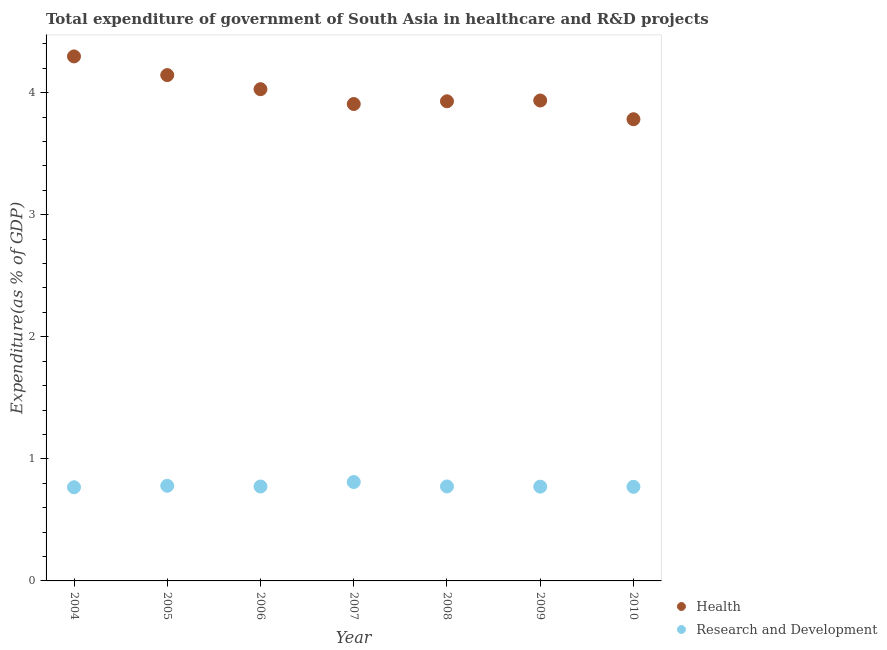Is the number of dotlines equal to the number of legend labels?
Provide a short and direct response. Yes. What is the expenditure in healthcare in 2006?
Ensure brevity in your answer.  4.03. Across all years, what is the maximum expenditure in healthcare?
Offer a terse response. 4.3. Across all years, what is the minimum expenditure in r&d?
Ensure brevity in your answer.  0.77. What is the total expenditure in healthcare in the graph?
Your answer should be very brief. 28.02. What is the difference between the expenditure in r&d in 2008 and that in 2009?
Your answer should be compact. 0. What is the difference between the expenditure in r&d in 2010 and the expenditure in healthcare in 2008?
Your answer should be very brief. -3.16. What is the average expenditure in healthcare per year?
Offer a very short reply. 4. In the year 2006, what is the difference between the expenditure in healthcare and expenditure in r&d?
Your answer should be very brief. 3.25. What is the ratio of the expenditure in healthcare in 2007 to that in 2009?
Give a very brief answer. 0.99. Is the expenditure in r&d in 2008 less than that in 2010?
Make the answer very short. No. Is the difference between the expenditure in r&d in 2006 and 2010 greater than the difference between the expenditure in healthcare in 2006 and 2010?
Make the answer very short. No. What is the difference between the highest and the second highest expenditure in healthcare?
Give a very brief answer. 0.15. What is the difference between the highest and the lowest expenditure in healthcare?
Offer a very short reply. 0.51. In how many years, is the expenditure in r&d greater than the average expenditure in r&d taken over all years?
Your answer should be compact. 2. Does the expenditure in healthcare monotonically increase over the years?
Give a very brief answer. No. Is the expenditure in r&d strictly greater than the expenditure in healthcare over the years?
Your answer should be compact. No. Is the expenditure in healthcare strictly less than the expenditure in r&d over the years?
Make the answer very short. No. How many dotlines are there?
Provide a short and direct response. 2. How many years are there in the graph?
Your answer should be very brief. 7. Does the graph contain any zero values?
Your response must be concise. No. How are the legend labels stacked?
Your answer should be compact. Vertical. What is the title of the graph?
Ensure brevity in your answer.  Total expenditure of government of South Asia in healthcare and R&D projects. Does "Savings" appear as one of the legend labels in the graph?
Give a very brief answer. No. What is the label or title of the Y-axis?
Offer a very short reply. Expenditure(as % of GDP). What is the Expenditure(as % of GDP) of Health in 2004?
Offer a very short reply. 4.3. What is the Expenditure(as % of GDP) of Research and Development in 2004?
Your answer should be compact. 0.77. What is the Expenditure(as % of GDP) of Health in 2005?
Offer a terse response. 4.14. What is the Expenditure(as % of GDP) of Research and Development in 2005?
Provide a succinct answer. 0.78. What is the Expenditure(as % of GDP) of Health in 2006?
Make the answer very short. 4.03. What is the Expenditure(as % of GDP) of Research and Development in 2006?
Your answer should be compact. 0.77. What is the Expenditure(as % of GDP) of Health in 2007?
Give a very brief answer. 3.91. What is the Expenditure(as % of GDP) in Research and Development in 2007?
Your answer should be very brief. 0.81. What is the Expenditure(as % of GDP) in Health in 2008?
Provide a succinct answer. 3.93. What is the Expenditure(as % of GDP) of Research and Development in 2008?
Your response must be concise. 0.77. What is the Expenditure(as % of GDP) in Health in 2009?
Offer a very short reply. 3.94. What is the Expenditure(as % of GDP) of Research and Development in 2009?
Offer a very short reply. 0.77. What is the Expenditure(as % of GDP) in Health in 2010?
Your answer should be very brief. 3.78. What is the Expenditure(as % of GDP) in Research and Development in 2010?
Your answer should be compact. 0.77. Across all years, what is the maximum Expenditure(as % of GDP) of Health?
Your answer should be very brief. 4.3. Across all years, what is the maximum Expenditure(as % of GDP) in Research and Development?
Provide a succinct answer. 0.81. Across all years, what is the minimum Expenditure(as % of GDP) in Health?
Provide a short and direct response. 3.78. Across all years, what is the minimum Expenditure(as % of GDP) in Research and Development?
Keep it short and to the point. 0.77. What is the total Expenditure(as % of GDP) of Health in the graph?
Offer a very short reply. 28.02. What is the total Expenditure(as % of GDP) in Research and Development in the graph?
Provide a succinct answer. 5.45. What is the difference between the Expenditure(as % of GDP) of Health in 2004 and that in 2005?
Provide a short and direct response. 0.15. What is the difference between the Expenditure(as % of GDP) of Research and Development in 2004 and that in 2005?
Your answer should be very brief. -0.01. What is the difference between the Expenditure(as % of GDP) in Health in 2004 and that in 2006?
Provide a short and direct response. 0.27. What is the difference between the Expenditure(as % of GDP) of Research and Development in 2004 and that in 2006?
Provide a short and direct response. -0.01. What is the difference between the Expenditure(as % of GDP) of Health in 2004 and that in 2007?
Offer a terse response. 0.39. What is the difference between the Expenditure(as % of GDP) of Research and Development in 2004 and that in 2007?
Your answer should be compact. -0.04. What is the difference between the Expenditure(as % of GDP) of Health in 2004 and that in 2008?
Offer a terse response. 0.37. What is the difference between the Expenditure(as % of GDP) in Research and Development in 2004 and that in 2008?
Give a very brief answer. -0.01. What is the difference between the Expenditure(as % of GDP) in Health in 2004 and that in 2009?
Offer a very short reply. 0.36. What is the difference between the Expenditure(as % of GDP) of Research and Development in 2004 and that in 2009?
Ensure brevity in your answer.  -0.01. What is the difference between the Expenditure(as % of GDP) of Health in 2004 and that in 2010?
Ensure brevity in your answer.  0.51. What is the difference between the Expenditure(as % of GDP) of Research and Development in 2004 and that in 2010?
Ensure brevity in your answer.  -0. What is the difference between the Expenditure(as % of GDP) in Health in 2005 and that in 2006?
Keep it short and to the point. 0.12. What is the difference between the Expenditure(as % of GDP) in Research and Development in 2005 and that in 2006?
Provide a succinct answer. 0.01. What is the difference between the Expenditure(as % of GDP) in Health in 2005 and that in 2007?
Make the answer very short. 0.24. What is the difference between the Expenditure(as % of GDP) in Research and Development in 2005 and that in 2007?
Keep it short and to the point. -0.03. What is the difference between the Expenditure(as % of GDP) of Health in 2005 and that in 2008?
Provide a short and direct response. 0.21. What is the difference between the Expenditure(as % of GDP) of Research and Development in 2005 and that in 2008?
Provide a short and direct response. 0.01. What is the difference between the Expenditure(as % of GDP) of Health in 2005 and that in 2009?
Give a very brief answer. 0.21. What is the difference between the Expenditure(as % of GDP) in Research and Development in 2005 and that in 2009?
Give a very brief answer. 0.01. What is the difference between the Expenditure(as % of GDP) of Health in 2005 and that in 2010?
Offer a terse response. 0.36. What is the difference between the Expenditure(as % of GDP) of Research and Development in 2005 and that in 2010?
Provide a succinct answer. 0.01. What is the difference between the Expenditure(as % of GDP) in Health in 2006 and that in 2007?
Provide a short and direct response. 0.12. What is the difference between the Expenditure(as % of GDP) in Research and Development in 2006 and that in 2007?
Offer a terse response. -0.04. What is the difference between the Expenditure(as % of GDP) of Health in 2006 and that in 2008?
Your answer should be very brief. 0.1. What is the difference between the Expenditure(as % of GDP) in Research and Development in 2006 and that in 2008?
Your answer should be compact. -0. What is the difference between the Expenditure(as % of GDP) of Health in 2006 and that in 2009?
Offer a terse response. 0.09. What is the difference between the Expenditure(as % of GDP) in Research and Development in 2006 and that in 2009?
Provide a succinct answer. 0. What is the difference between the Expenditure(as % of GDP) of Health in 2006 and that in 2010?
Keep it short and to the point. 0.25. What is the difference between the Expenditure(as % of GDP) in Research and Development in 2006 and that in 2010?
Make the answer very short. 0. What is the difference between the Expenditure(as % of GDP) of Health in 2007 and that in 2008?
Your answer should be very brief. -0.02. What is the difference between the Expenditure(as % of GDP) in Research and Development in 2007 and that in 2008?
Your response must be concise. 0.04. What is the difference between the Expenditure(as % of GDP) in Health in 2007 and that in 2009?
Your answer should be very brief. -0.03. What is the difference between the Expenditure(as % of GDP) of Research and Development in 2007 and that in 2009?
Ensure brevity in your answer.  0.04. What is the difference between the Expenditure(as % of GDP) of Health in 2007 and that in 2010?
Provide a short and direct response. 0.12. What is the difference between the Expenditure(as % of GDP) of Research and Development in 2007 and that in 2010?
Make the answer very short. 0.04. What is the difference between the Expenditure(as % of GDP) in Health in 2008 and that in 2009?
Offer a terse response. -0.01. What is the difference between the Expenditure(as % of GDP) in Research and Development in 2008 and that in 2009?
Make the answer very short. 0. What is the difference between the Expenditure(as % of GDP) of Health in 2008 and that in 2010?
Your response must be concise. 0.15. What is the difference between the Expenditure(as % of GDP) of Research and Development in 2008 and that in 2010?
Offer a terse response. 0. What is the difference between the Expenditure(as % of GDP) of Health in 2009 and that in 2010?
Your answer should be very brief. 0.15. What is the difference between the Expenditure(as % of GDP) in Research and Development in 2009 and that in 2010?
Give a very brief answer. 0. What is the difference between the Expenditure(as % of GDP) in Health in 2004 and the Expenditure(as % of GDP) in Research and Development in 2005?
Ensure brevity in your answer.  3.52. What is the difference between the Expenditure(as % of GDP) in Health in 2004 and the Expenditure(as % of GDP) in Research and Development in 2006?
Make the answer very short. 3.52. What is the difference between the Expenditure(as % of GDP) of Health in 2004 and the Expenditure(as % of GDP) of Research and Development in 2007?
Provide a short and direct response. 3.49. What is the difference between the Expenditure(as % of GDP) of Health in 2004 and the Expenditure(as % of GDP) of Research and Development in 2008?
Your answer should be very brief. 3.52. What is the difference between the Expenditure(as % of GDP) of Health in 2004 and the Expenditure(as % of GDP) of Research and Development in 2009?
Keep it short and to the point. 3.52. What is the difference between the Expenditure(as % of GDP) in Health in 2004 and the Expenditure(as % of GDP) in Research and Development in 2010?
Keep it short and to the point. 3.53. What is the difference between the Expenditure(as % of GDP) of Health in 2005 and the Expenditure(as % of GDP) of Research and Development in 2006?
Provide a succinct answer. 3.37. What is the difference between the Expenditure(as % of GDP) of Health in 2005 and the Expenditure(as % of GDP) of Research and Development in 2007?
Your answer should be very brief. 3.33. What is the difference between the Expenditure(as % of GDP) in Health in 2005 and the Expenditure(as % of GDP) in Research and Development in 2008?
Provide a succinct answer. 3.37. What is the difference between the Expenditure(as % of GDP) in Health in 2005 and the Expenditure(as % of GDP) in Research and Development in 2009?
Keep it short and to the point. 3.37. What is the difference between the Expenditure(as % of GDP) in Health in 2005 and the Expenditure(as % of GDP) in Research and Development in 2010?
Your answer should be very brief. 3.37. What is the difference between the Expenditure(as % of GDP) in Health in 2006 and the Expenditure(as % of GDP) in Research and Development in 2007?
Your response must be concise. 3.22. What is the difference between the Expenditure(as % of GDP) of Health in 2006 and the Expenditure(as % of GDP) of Research and Development in 2008?
Give a very brief answer. 3.25. What is the difference between the Expenditure(as % of GDP) in Health in 2006 and the Expenditure(as % of GDP) in Research and Development in 2009?
Keep it short and to the point. 3.26. What is the difference between the Expenditure(as % of GDP) in Health in 2006 and the Expenditure(as % of GDP) in Research and Development in 2010?
Keep it short and to the point. 3.26. What is the difference between the Expenditure(as % of GDP) of Health in 2007 and the Expenditure(as % of GDP) of Research and Development in 2008?
Give a very brief answer. 3.13. What is the difference between the Expenditure(as % of GDP) in Health in 2007 and the Expenditure(as % of GDP) in Research and Development in 2009?
Make the answer very short. 3.13. What is the difference between the Expenditure(as % of GDP) in Health in 2007 and the Expenditure(as % of GDP) in Research and Development in 2010?
Make the answer very short. 3.14. What is the difference between the Expenditure(as % of GDP) of Health in 2008 and the Expenditure(as % of GDP) of Research and Development in 2009?
Your answer should be compact. 3.16. What is the difference between the Expenditure(as % of GDP) of Health in 2008 and the Expenditure(as % of GDP) of Research and Development in 2010?
Keep it short and to the point. 3.16. What is the difference between the Expenditure(as % of GDP) of Health in 2009 and the Expenditure(as % of GDP) of Research and Development in 2010?
Your answer should be compact. 3.16. What is the average Expenditure(as % of GDP) of Health per year?
Provide a succinct answer. 4. What is the average Expenditure(as % of GDP) of Research and Development per year?
Provide a succinct answer. 0.78. In the year 2004, what is the difference between the Expenditure(as % of GDP) in Health and Expenditure(as % of GDP) in Research and Development?
Your response must be concise. 3.53. In the year 2005, what is the difference between the Expenditure(as % of GDP) in Health and Expenditure(as % of GDP) in Research and Development?
Keep it short and to the point. 3.36. In the year 2006, what is the difference between the Expenditure(as % of GDP) of Health and Expenditure(as % of GDP) of Research and Development?
Provide a short and direct response. 3.25. In the year 2007, what is the difference between the Expenditure(as % of GDP) in Health and Expenditure(as % of GDP) in Research and Development?
Ensure brevity in your answer.  3.1. In the year 2008, what is the difference between the Expenditure(as % of GDP) in Health and Expenditure(as % of GDP) in Research and Development?
Provide a succinct answer. 3.16. In the year 2009, what is the difference between the Expenditure(as % of GDP) in Health and Expenditure(as % of GDP) in Research and Development?
Provide a short and direct response. 3.16. In the year 2010, what is the difference between the Expenditure(as % of GDP) in Health and Expenditure(as % of GDP) in Research and Development?
Your answer should be compact. 3.01. What is the ratio of the Expenditure(as % of GDP) in Health in 2004 to that in 2005?
Make the answer very short. 1.04. What is the ratio of the Expenditure(as % of GDP) of Research and Development in 2004 to that in 2005?
Offer a very short reply. 0.98. What is the ratio of the Expenditure(as % of GDP) of Health in 2004 to that in 2006?
Your answer should be compact. 1.07. What is the ratio of the Expenditure(as % of GDP) of Research and Development in 2004 to that in 2006?
Provide a short and direct response. 0.99. What is the ratio of the Expenditure(as % of GDP) of Health in 2004 to that in 2007?
Your answer should be compact. 1.1. What is the ratio of the Expenditure(as % of GDP) of Research and Development in 2004 to that in 2007?
Your answer should be very brief. 0.95. What is the ratio of the Expenditure(as % of GDP) of Health in 2004 to that in 2008?
Your answer should be compact. 1.09. What is the ratio of the Expenditure(as % of GDP) of Research and Development in 2004 to that in 2008?
Make the answer very short. 0.99. What is the ratio of the Expenditure(as % of GDP) of Health in 2004 to that in 2009?
Offer a terse response. 1.09. What is the ratio of the Expenditure(as % of GDP) in Health in 2004 to that in 2010?
Offer a terse response. 1.14. What is the ratio of the Expenditure(as % of GDP) in Research and Development in 2004 to that in 2010?
Provide a succinct answer. 1. What is the ratio of the Expenditure(as % of GDP) in Health in 2005 to that in 2006?
Make the answer very short. 1.03. What is the ratio of the Expenditure(as % of GDP) in Research and Development in 2005 to that in 2006?
Your response must be concise. 1.01. What is the ratio of the Expenditure(as % of GDP) in Health in 2005 to that in 2007?
Offer a very short reply. 1.06. What is the ratio of the Expenditure(as % of GDP) in Research and Development in 2005 to that in 2007?
Keep it short and to the point. 0.96. What is the ratio of the Expenditure(as % of GDP) in Health in 2005 to that in 2008?
Give a very brief answer. 1.05. What is the ratio of the Expenditure(as % of GDP) in Health in 2005 to that in 2009?
Ensure brevity in your answer.  1.05. What is the ratio of the Expenditure(as % of GDP) of Research and Development in 2005 to that in 2009?
Ensure brevity in your answer.  1.01. What is the ratio of the Expenditure(as % of GDP) in Health in 2005 to that in 2010?
Your answer should be very brief. 1.1. What is the ratio of the Expenditure(as % of GDP) of Research and Development in 2005 to that in 2010?
Make the answer very short. 1.01. What is the ratio of the Expenditure(as % of GDP) of Health in 2006 to that in 2007?
Your response must be concise. 1.03. What is the ratio of the Expenditure(as % of GDP) in Research and Development in 2006 to that in 2007?
Your answer should be very brief. 0.95. What is the ratio of the Expenditure(as % of GDP) in Health in 2006 to that in 2008?
Offer a terse response. 1.03. What is the ratio of the Expenditure(as % of GDP) of Research and Development in 2006 to that in 2008?
Your answer should be very brief. 1. What is the ratio of the Expenditure(as % of GDP) of Health in 2006 to that in 2009?
Your answer should be compact. 1.02. What is the ratio of the Expenditure(as % of GDP) of Research and Development in 2006 to that in 2009?
Make the answer very short. 1. What is the ratio of the Expenditure(as % of GDP) of Health in 2006 to that in 2010?
Your answer should be compact. 1.07. What is the ratio of the Expenditure(as % of GDP) of Research and Development in 2007 to that in 2008?
Ensure brevity in your answer.  1.05. What is the ratio of the Expenditure(as % of GDP) of Health in 2007 to that in 2009?
Ensure brevity in your answer.  0.99. What is the ratio of the Expenditure(as % of GDP) of Research and Development in 2007 to that in 2009?
Offer a very short reply. 1.05. What is the ratio of the Expenditure(as % of GDP) of Health in 2007 to that in 2010?
Provide a succinct answer. 1.03. What is the ratio of the Expenditure(as % of GDP) in Research and Development in 2007 to that in 2010?
Your answer should be compact. 1.05. What is the ratio of the Expenditure(as % of GDP) of Health in 2008 to that in 2009?
Offer a terse response. 1. What is the ratio of the Expenditure(as % of GDP) of Health in 2008 to that in 2010?
Your answer should be very brief. 1.04. What is the ratio of the Expenditure(as % of GDP) in Research and Development in 2008 to that in 2010?
Keep it short and to the point. 1. What is the ratio of the Expenditure(as % of GDP) in Health in 2009 to that in 2010?
Give a very brief answer. 1.04. What is the difference between the highest and the second highest Expenditure(as % of GDP) in Health?
Your answer should be compact. 0.15. What is the difference between the highest and the second highest Expenditure(as % of GDP) of Research and Development?
Your answer should be very brief. 0.03. What is the difference between the highest and the lowest Expenditure(as % of GDP) in Health?
Your response must be concise. 0.51. What is the difference between the highest and the lowest Expenditure(as % of GDP) in Research and Development?
Give a very brief answer. 0.04. 